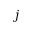Convert formula to latex. <formula><loc_0><loc_0><loc_500><loc_500>j</formula> 